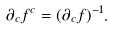Convert formula to latex. <formula><loc_0><loc_0><loc_500><loc_500>\partial _ { c } f ^ { c } = ( \partial _ { c } f ) ^ { - 1 } .</formula> 